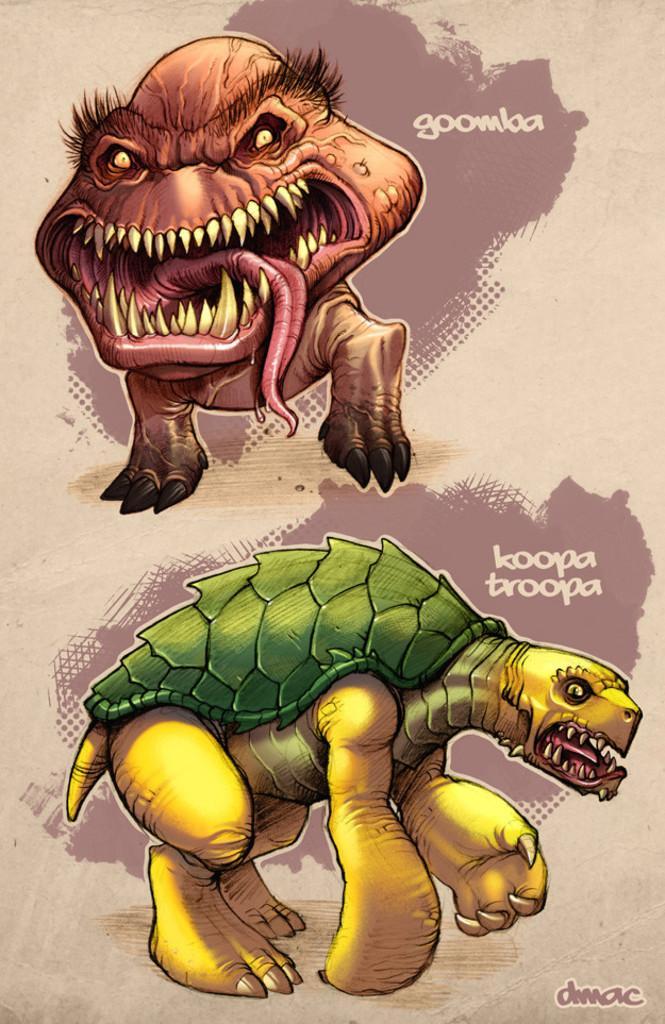How would you summarize this image in a sentence or two? These are the two animated pictures, at the bottom it is in the shape of tortoise. 